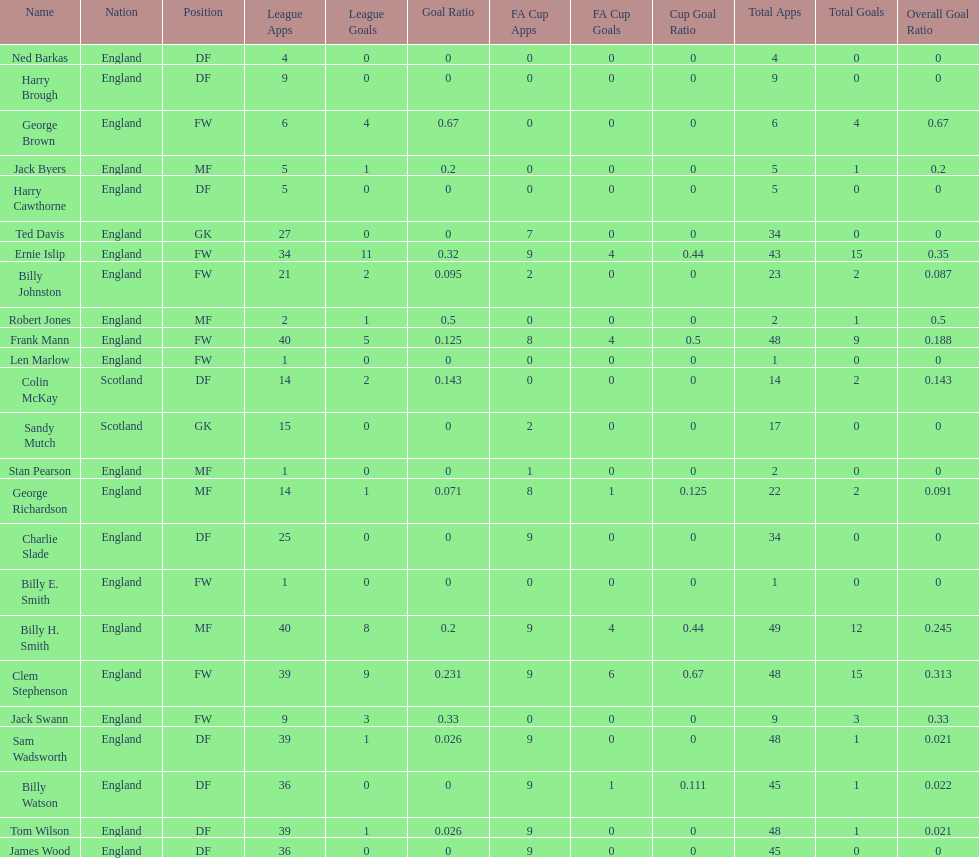Which position is listed the least amount of times on this chart? GK. 